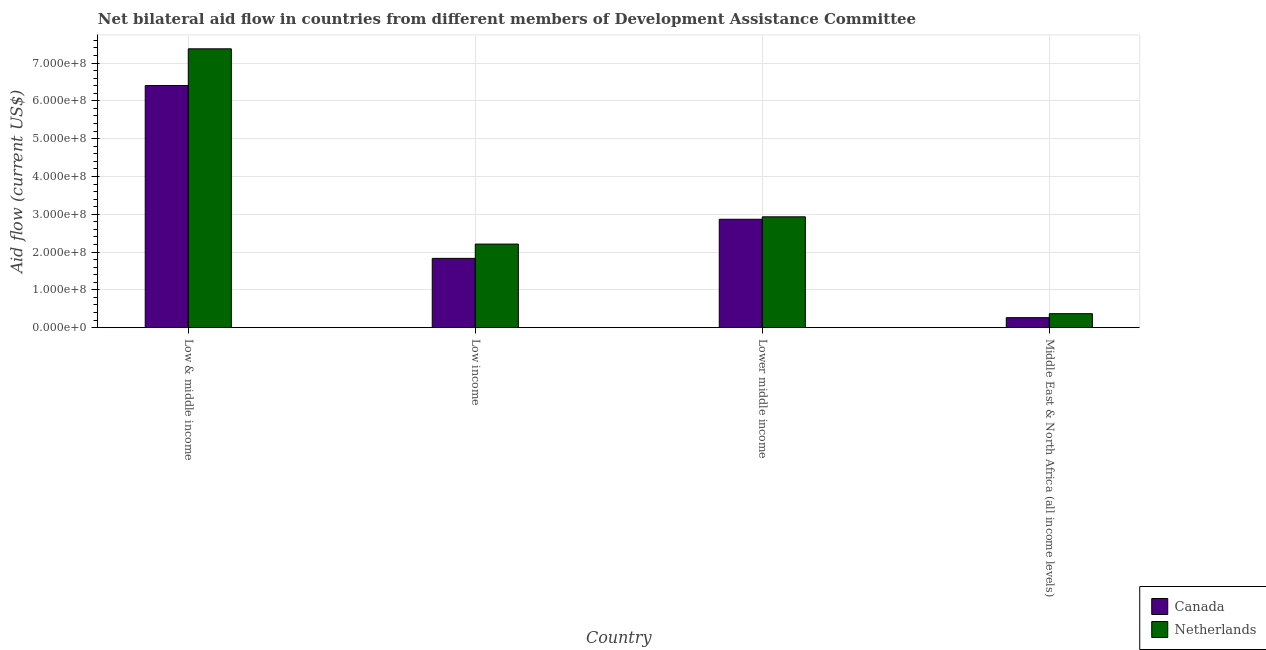Are the number of bars on each tick of the X-axis equal?
Provide a short and direct response. Yes. How many bars are there on the 4th tick from the left?
Keep it short and to the point. 2. How many bars are there on the 4th tick from the right?
Offer a very short reply. 2. What is the label of the 4th group of bars from the left?
Your answer should be very brief. Middle East & North Africa (all income levels). What is the amount of aid given by canada in Low & middle income?
Your answer should be very brief. 6.41e+08. Across all countries, what is the maximum amount of aid given by canada?
Your answer should be compact. 6.41e+08. Across all countries, what is the minimum amount of aid given by canada?
Provide a succinct answer. 2.65e+07. In which country was the amount of aid given by canada maximum?
Your answer should be very brief. Low & middle income. In which country was the amount of aid given by netherlands minimum?
Offer a very short reply. Middle East & North Africa (all income levels). What is the total amount of aid given by canada in the graph?
Your answer should be compact. 1.14e+09. What is the difference between the amount of aid given by netherlands in Low & middle income and that in Middle East & North Africa (all income levels)?
Offer a very short reply. 7.01e+08. What is the difference between the amount of aid given by netherlands in Lower middle income and the amount of aid given by canada in Low & middle income?
Provide a succinct answer. -3.47e+08. What is the average amount of aid given by canada per country?
Make the answer very short. 2.84e+08. What is the difference between the amount of aid given by canada and amount of aid given by netherlands in Low income?
Offer a very short reply. -3.78e+07. In how many countries, is the amount of aid given by canada greater than 540000000 US$?
Make the answer very short. 1. What is the ratio of the amount of aid given by canada in Low & middle income to that in Low income?
Ensure brevity in your answer.  3.5. What is the difference between the highest and the second highest amount of aid given by canada?
Make the answer very short. 3.54e+08. What is the difference between the highest and the lowest amount of aid given by netherlands?
Offer a very short reply. 7.01e+08. What does the 2nd bar from the left in Low income represents?
Your answer should be compact. Netherlands. What does the 2nd bar from the right in Lower middle income represents?
Ensure brevity in your answer.  Canada. How many bars are there?
Provide a short and direct response. 8. Are all the bars in the graph horizontal?
Your answer should be compact. No. How many countries are there in the graph?
Your response must be concise. 4. What is the difference between two consecutive major ticks on the Y-axis?
Offer a terse response. 1.00e+08. Are the values on the major ticks of Y-axis written in scientific E-notation?
Give a very brief answer. Yes. Does the graph contain grids?
Offer a very short reply. Yes. Where does the legend appear in the graph?
Provide a succinct answer. Bottom right. How many legend labels are there?
Offer a very short reply. 2. How are the legend labels stacked?
Give a very brief answer. Vertical. What is the title of the graph?
Offer a terse response. Net bilateral aid flow in countries from different members of Development Assistance Committee. What is the label or title of the X-axis?
Offer a very short reply. Country. What is the Aid flow (current US$) of Canada in Low & middle income?
Your answer should be compact. 6.41e+08. What is the Aid flow (current US$) in Netherlands in Low & middle income?
Your response must be concise. 7.38e+08. What is the Aid flow (current US$) of Canada in Low income?
Provide a short and direct response. 1.83e+08. What is the Aid flow (current US$) of Netherlands in Low income?
Offer a very short reply. 2.21e+08. What is the Aid flow (current US$) in Canada in Lower middle income?
Your response must be concise. 2.87e+08. What is the Aid flow (current US$) in Netherlands in Lower middle income?
Your answer should be very brief. 2.93e+08. What is the Aid flow (current US$) in Canada in Middle East & North Africa (all income levels)?
Provide a succinct answer. 2.65e+07. What is the Aid flow (current US$) in Netherlands in Middle East & North Africa (all income levels)?
Offer a terse response. 3.70e+07. Across all countries, what is the maximum Aid flow (current US$) of Canada?
Make the answer very short. 6.41e+08. Across all countries, what is the maximum Aid flow (current US$) of Netherlands?
Give a very brief answer. 7.38e+08. Across all countries, what is the minimum Aid flow (current US$) in Canada?
Provide a short and direct response. 2.65e+07. Across all countries, what is the minimum Aid flow (current US$) of Netherlands?
Offer a very short reply. 3.70e+07. What is the total Aid flow (current US$) in Canada in the graph?
Give a very brief answer. 1.14e+09. What is the total Aid flow (current US$) of Netherlands in the graph?
Make the answer very short. 1.29e+09. What is the difference between the Aid flow (current US$) in Canada in Low & middle income and that in Low income?
Your answer should be very brief. 4.57e+08. What is the difference between the Aid flow (current US$) in Netherlands in Low & middle income and that in Low income?
Offer a terse response. 5.17e+08. What is the difference between the Aid flow (current US$) in Canada in Low & middle income and that in Lower middle income?
Your answer should be compact. 3.54e+08. What is the difference between the Aid flow (current US$) in Netherlands in Low & middle income and that in Lower middle income?
Your answer should be very brief. 4.44e+08. What is the difference between the Aid flow (current US$) in Canada in Low & middle income and that in Middle East & North Africa (all income levels)?
Your response must be concise. 6.14e+08. What is the difference between the Aid flow (current US$) in Netherlands in Low & middle income and that in Middle East & North Africa (all income levels)?
Your answer should be compact. 7.01e+08. What is the difference between the Aid flow (current US$) of Canada in Low income and that in Lower middle income?
Your answer should be compact. -1.03e+08. What is the difference between the Aid flow (current US$) in Netherlands in Low income and that in Lower middle income?
Offer a very short reply. -7.21e+07. What is the difference between the Aid flow (current US$) of Canada in Low income and that in Middle East & North Africa (all income levels)?
Provide a succinct answer. 1.57e+08. What is the difference between the Aid flow (current US$) of Netherlands in Low income and that in Middle East & North Africa (all income levels)?
Keep it short and to the point. 1.84e+08. What is the difference between the Aid flow (current US$) of Canada in Lower middle income and that in Middle East & North Africa (all income levels)?
Your response must be concise. 2.60e+08. What is the difference between the Aid flow (current US$) in Netherlands in Lower middle income and that in Middle East & North Africa (all income levels)?
Offer a very short reply. 2.56e+08. What is the difference between the Aid flow (current US$) of Canada in Low & middle income and the Aid flow (current US$) of Netherlands in Low income?
Offer a terse response. 4.19e+08. What is the difference between the Aid flow (current US$) in Canada in Low & middle income and the Aid flow (current US$) in Netherlands in Lower middle income?
Keep it short and to the point. 3.47e+08. What is the difference between the Aid flow (current US$) in Canada in Low & middle income and the Aid flow (current US$) in Netherlands in Middle East & North Africa (all income levels)?
Provide a succinct answer. 6.04e+08. What is the difference between the Aid flow (current US$) in Canada in Low income and the Aid flow (current US$) in Netherlands in Lower middle income?
Your answer should be very brief. -1.10e+08. What is the difference between the Aid flow (current US$) of Canada in Low income and the Aid flow (current US$) of Netherlands in Middle East & North Africa (all income levels)?
Give a very brief answer. 1.46e+08. What is the difference between the Aid flow (current US$) in Canada in Lower middle income and the Aid flow (current US$) in Netherlands in Middle East & North Africa (all income levels)?
Your answer should be very brief. 2.50e+08. What is the average Aid flow (current US$) of Canada per country?
Provide a short and direct response. 2.84e+08. What is the average Aid flow (current US$) in Netherlands per country?
Offer a terse response. 3.22e+08. What is the difference between the Aid flow (current US$) in Canada and Aid flow (current US$) in Netherlands in Low & middle income?
Ensure brevity in your answer.  -9.71e+07. What is the difference between the Aid flow (current US$) in Canada and Aid flow (current US$) in Netherlands in Low income?
Your answer should be compact. -3.78e+07. What is the difference between the Aid flow (current US$) of Canada and Aid flow (current US$) of Netherlands in Lower middle income?
Make the answer very short. -6.51e+06. What is the difference between the Aid flow (current US$) of Canada and Aid flow (current US$) of Netherlands in Middle East & North Africa (all income levels)?
Provide a short and direct response. -1.05e+07. What is the ratio of the Aid flow (current US$) of Canada in Low & middle income to that in Low income?
Provide a succinct answer. 3.5. What is the ratio of the Aid flow (current US$) in Netherlands in Low & middle income to that in Low income?
Offer a very short reply. 3.34. What is the ratio of the Aid flow (current US$) of Canada in Low & middle income to that in Lower middle income?
Provide a short and direct response. 2.23. What is the ratio of the Aid flow (current US$) of Netherlands in Low & middle income to that in Lower middle income?
Provide a succinct answer. 2.52. What is the ratio of the Aid flow (current US$) of Canada in Low & middle income to that in Middle East & North Africa (all income levels)?
Your answer should be very brief. 24.2. What is the ratio of the Aid flow (current US$) in Netherlands in Low & middle income to that in Middle East & North Africa (all income levels)?
Ensure brevity in your answer.  19.94. What is the ratio of the Aid flow (current US$) of Canada in Low income to that in Lower middle income?
Provide a short and direct response. 0.64. What is the ratio of the Aid flow (current US$) in Netherlands in Low income to that in Lower middle income?
Your response must be concise. 0.75. What is the ratio of the Aid flow (current US$) of Canada in Low income to that in Middle East & North Africa (all income levels)?
Offer a very short reply. 6.92. What is the ratio of the Aid flow (current US$) of Netherlands in Low income to that in Middle East & North Africa (all income levels)?
Make the answer very short. 5.98. What is the ratio of the Aid flow (current US$) of Canada in Lower middle income to that in Middle East & North Africa (all income levels)?
Offer a terse response. 10.83. What is the ratio of the Aid flow (current US$) in Netherlands in Lower middle income to that in Middle East & North Africa (all income levels)?
Your answer should be compact. 7.93. What is the difference between the highest and the second highest Aid flow (current US$) of Canada?
Provide a short and direct response. 3.54e+08. What is the difference between the highest and the second highest Aid flow (current US$) of Netherlands?
Keep it short and to the point. 4.44e+08. What is the difference between the highest and the lowest Aid flow (current US$) of Canada?
Offer a very short reply. 6.14e+08. What is the difference between the highest and the lowest Aid flow (current US$) in Netherlands?
Make the answer very short. 7.01e+08. 